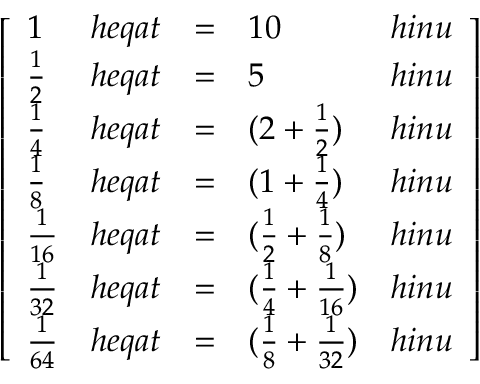Convert formula to latex. <formula><loc_0><loc_0><loc_500><loc_500>{ \left [ \begin{array} { l l l l l } { 1 } & { h e q a t } & { = } & { 1 0 } & { h i n u } \\ { { \frac { 1 } { 2 } } } & { h e q a t } & { = } & { 5 } & { h i n u } \\ { { \frac { 1 } { 4 } } } & { h e q a t } & { = } & { ( 2 + { \frac { 1 } { 2 } } ) } & { h i n u } \\ { { \frac { 1 } { 8 } } } & { h e q a t } & { = } & { ( 1 + { \frac { 1 } { 4 } } ) } & { h i n u } \\ { { \frac { 1 } { 1 6 } } } & { h e q a t } & { = } & { ( { \frac { 1 } { 2 } } + { \frac { 1 } { 8 } } ) } & { h i n u } \\ { { \frac { 1 } { 3 2 } } } & { h e q a t } & { = } & { ( { \frac { 1 } { 4 } } + { \frac { 1 } { 1 6 } } ) } & { h i n u } \\ { { \frac { 1 } { 6 4 } } } & { h e q a t } & { = } & { ( { \frac { 1 } { 8 } } + { \frac { 1 } { 3 2 } } ) } & { h i n u } \end{array} \right ] }</formula> 